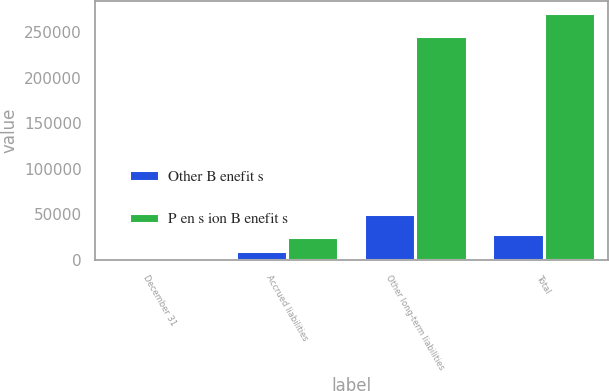<chart> <loc_0><loc_0><loc_500><loc_500><stacked_bar_chart><ecel><fcel>December 31<fcel>Accrued liabilities<fcel>Other long-term liabilities<fcel>Total<nl><fcel>Other B enefit s<fcel>2013<fcel>10198<fcel>50842<fcel>28507<nl><fcel>P en s ion B enefit s<fcel>2013<fcel>25477<fcel>245460<fcel>270937<nl></chart> 